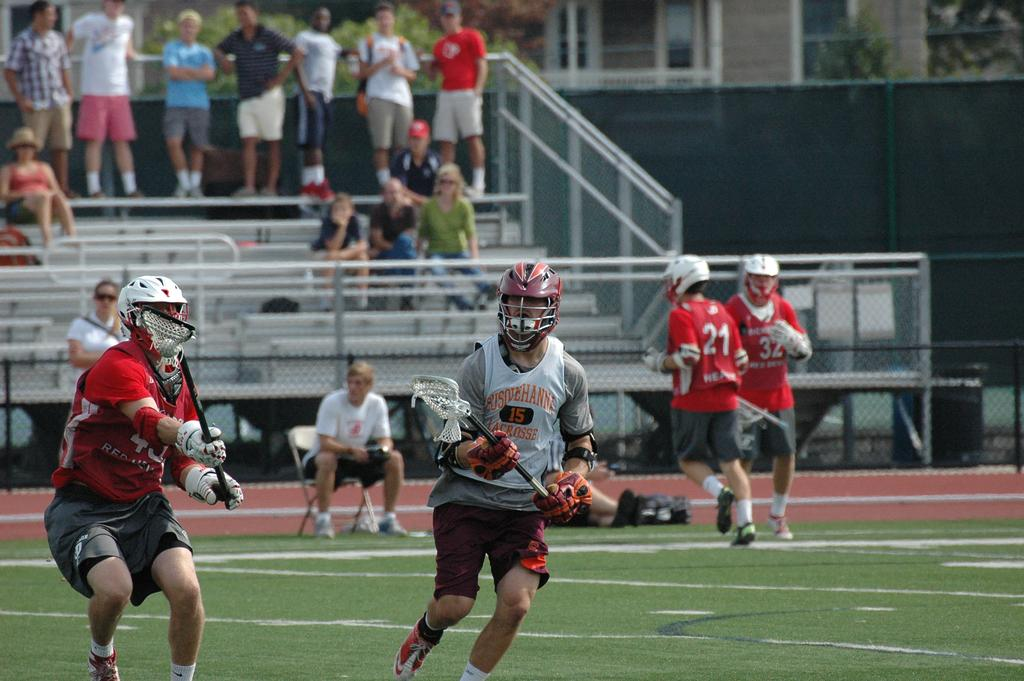What are the people in the image doing? There are people playing in a ground, some people are sitting, and some people are standing and watching. Can you describe the activities of the people in the image? Some people are actively playing, while others are observing the game. How many people are sitting in the image? The fact does not specify the exact number of people sitting, but it is mentioned that some people are sitting. What type of stocking is being worn by the representative in the image? There is no representative or stocking mentioned in the image; it only shows people playing, sitting, and standing. 